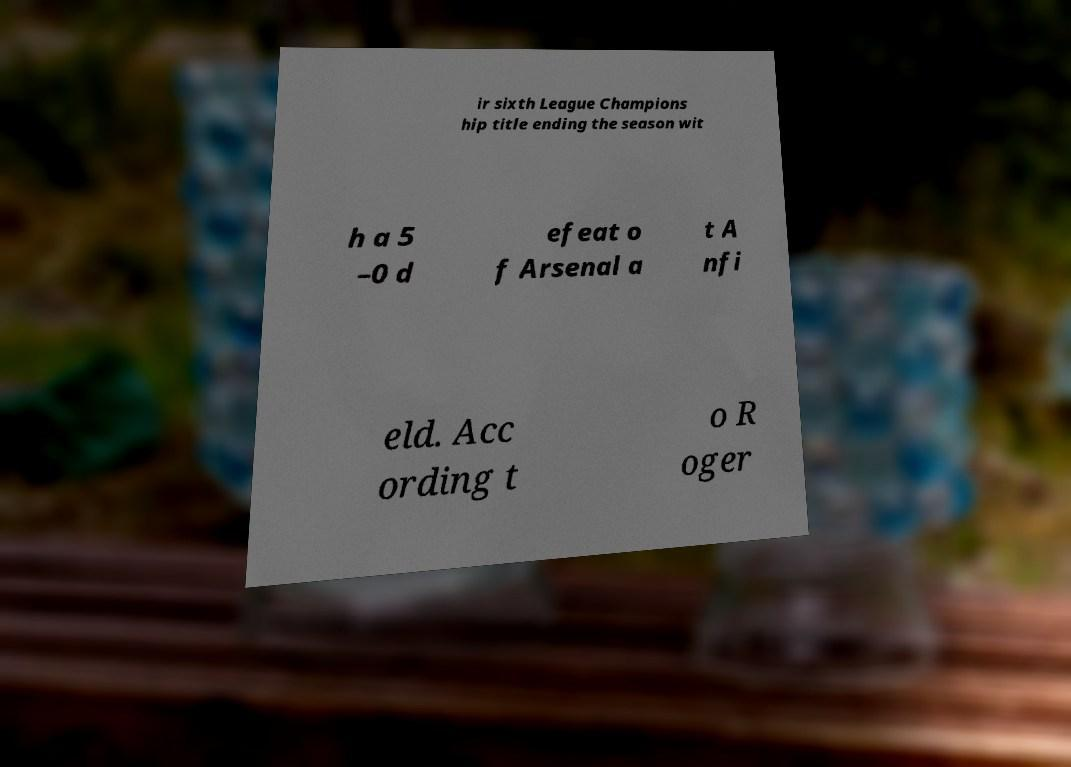What messages or text are displayed in this image? I need them in a readable, typed format. ir sixth League Champions hip title ending the season wit h a 5 –0 d efeat o f Arsenal a t A nfi eld. Acc ording t o R oger 